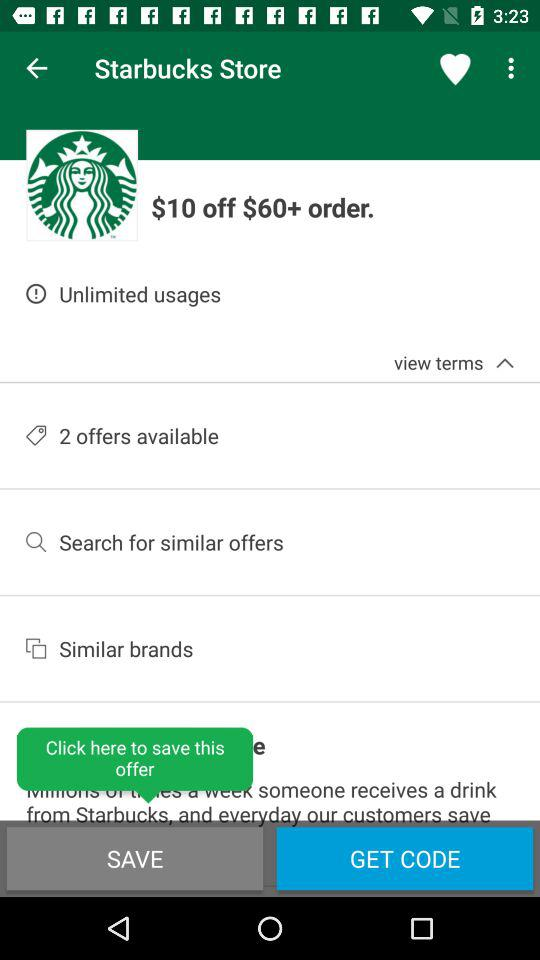How much discount is available on orders above $60? The discount is $10. 